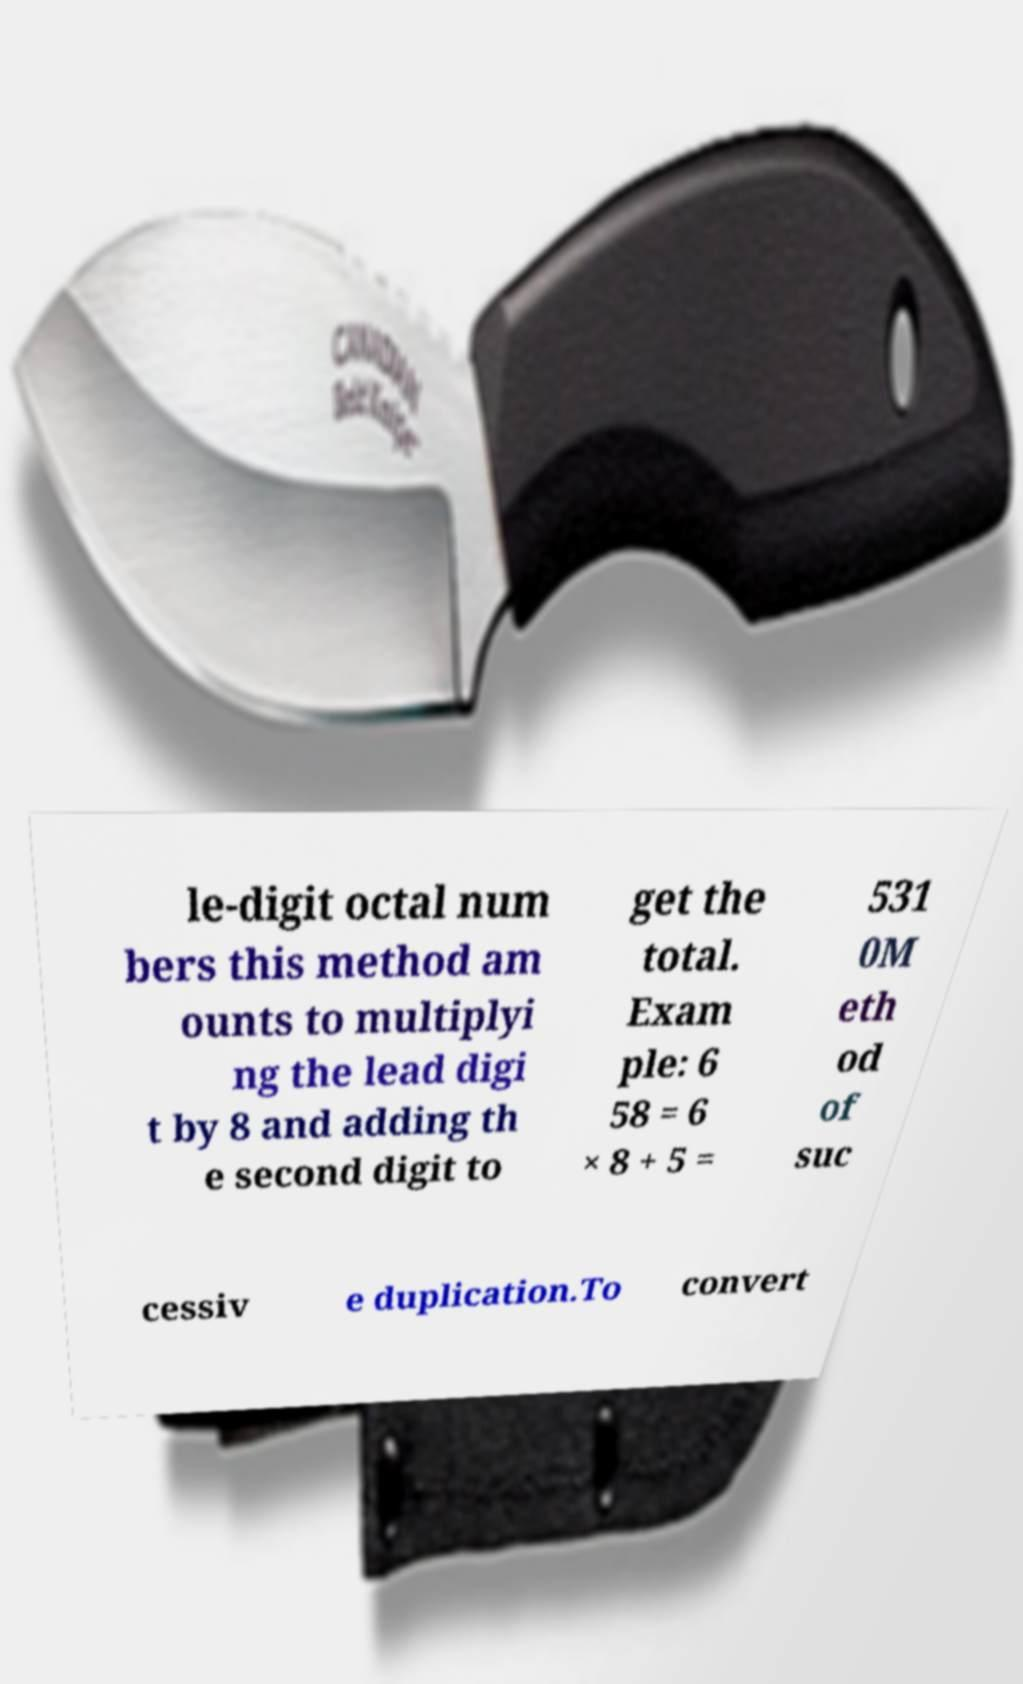For documentation purposes, I need the text within this image transcribed. Could you provide that? le-digit octal num bers this method am ounts to multiplyi ng the lead digi t by 8 and adding th e second digit to get the total. Exam ple: 6 58 = 6 × 8 + 5 = 531 0M eth od of suc cessiv e duplication.To convert 